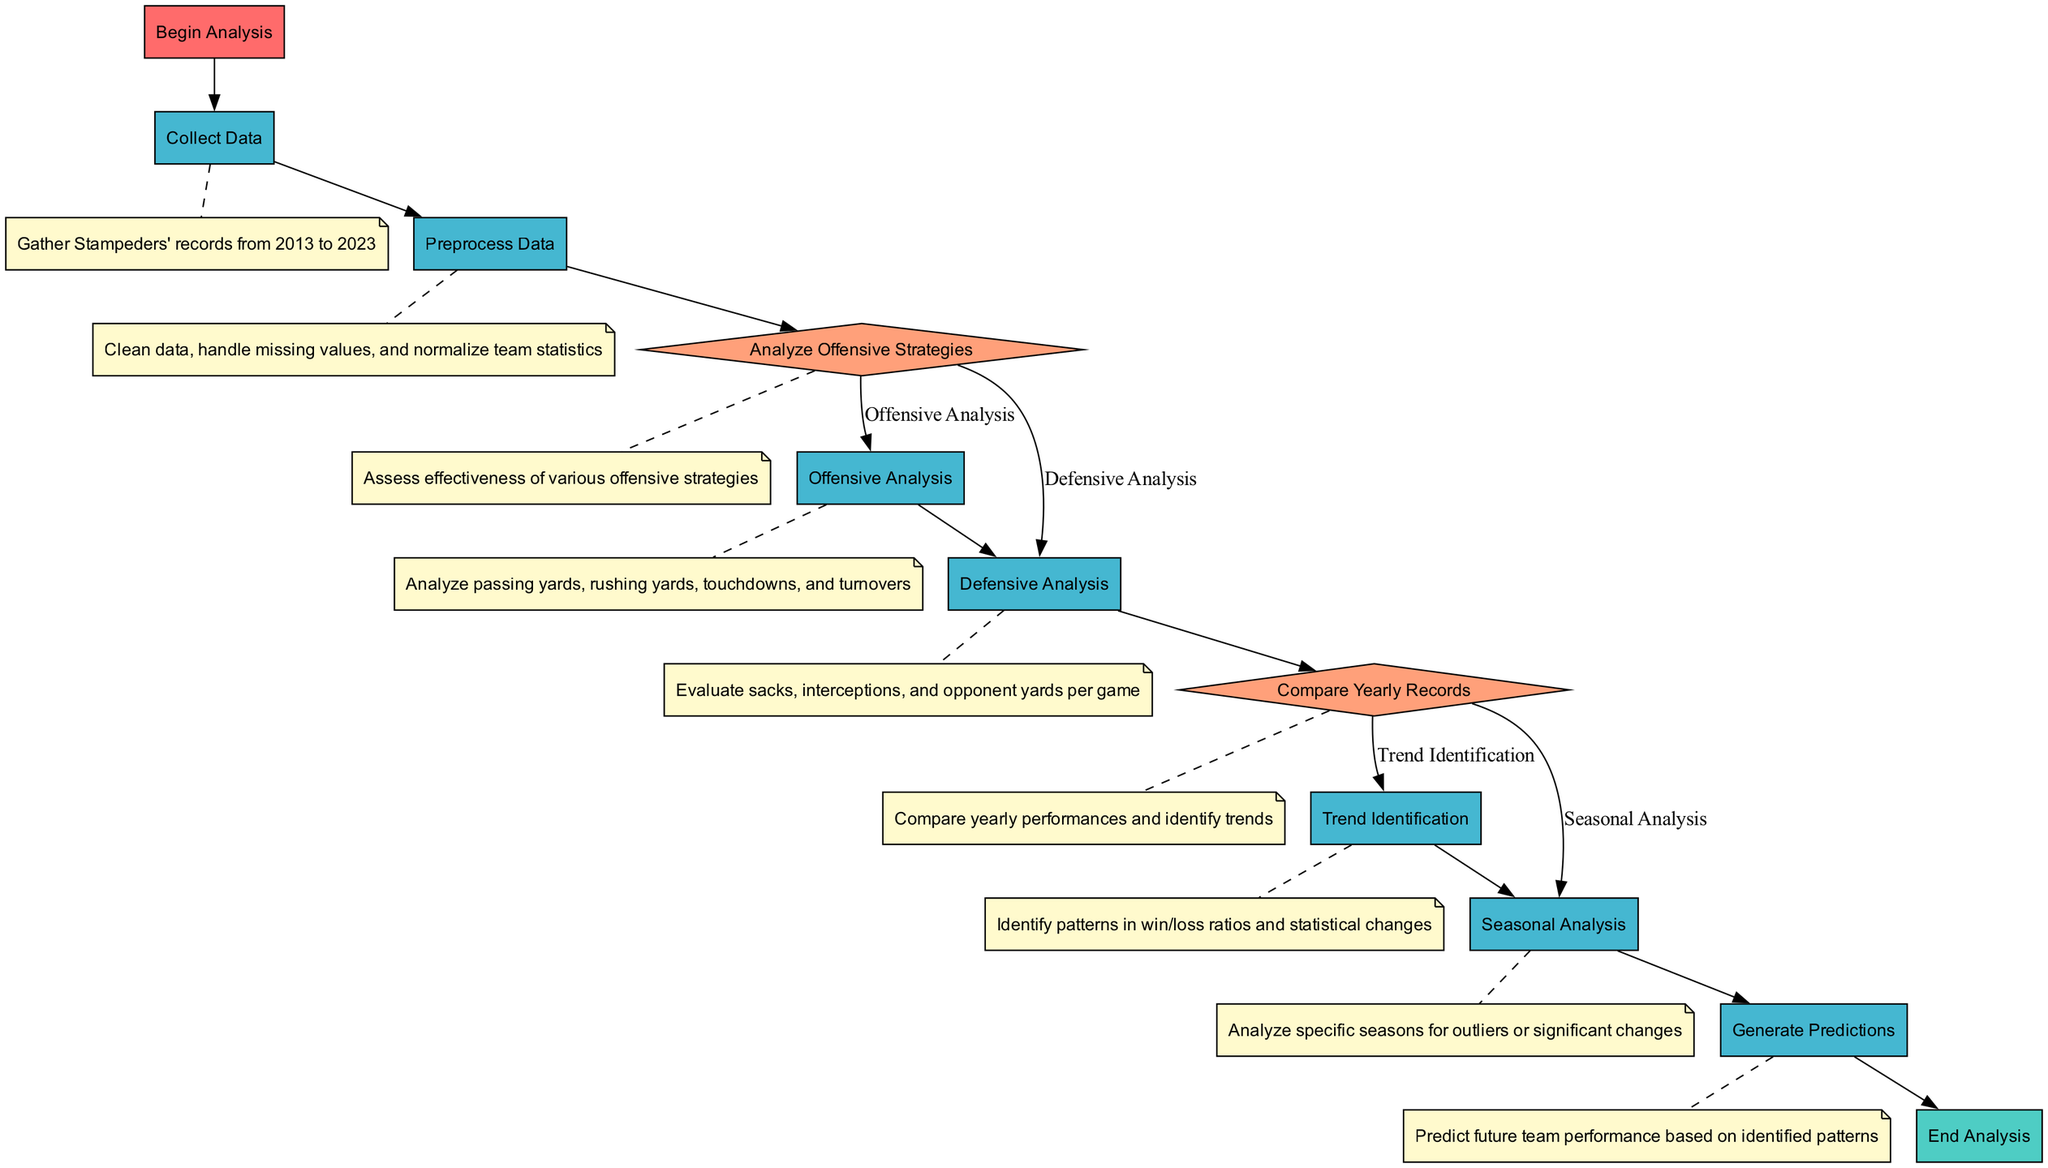What is the starting node of the flowchart? The flowchart begins with the "Begin Analysis" node, which is the first element in the diagram.
Answer: Begin Analysis How many processes are present in the diagram? Counting the nodes categorized as "Process", there are five distinct processes listed in the diagram.
Answer: Five What happens after "Collect Data"? After "Collect Data", the next node is "Preprocess Data", indicating that data cleaning and handling occurs next.
Answer: Preprocess Data What are the two possible branches from the "Analyze Offensive Strategies" decision? The decision can lead to two branches: "Offensive Analysis" if true, and "Defensive Analysis" if false.
Answer: Offensive Analysis and Defensive Analysis How many nodes are labeled with "Analysis"? The flowchart includes three nodes specifically labeled with "Analysis": "Offensive Analysis," "Defensive Analysis," and "Seasonal Analysis."
Answer: Three What step occurs if the yearly records result is true? If the yearly records comparison is true, the process leads to the "Trend Identification" node for further pattern analysis.
Answer: Trend Identification What occurs after "Trend Identification"? Following "Trend Identification", the next step is "Generate Predictions", where future performances are forecasted based on the identified trends.
Answer: Generate Predictions What is the endpoint of the analysis? The endpoint of the analysis is represented by the "End Analysis" node, which signifies the conclusion of the flowchart.
Answer: End Analysis Which node involves evaluating defensive statistics? The evaluation of defensive statistics is conducted in the "Defensive Analysis" node, where sacks and interceptions are assessed.
Answer: Defensive Analysis What is represented by the "End" node in the flowchart? The "End" node signifies the conclusion of the entire analysis process, indicating that no further steps are applicable beyond this point.
Answer: End Analysis 